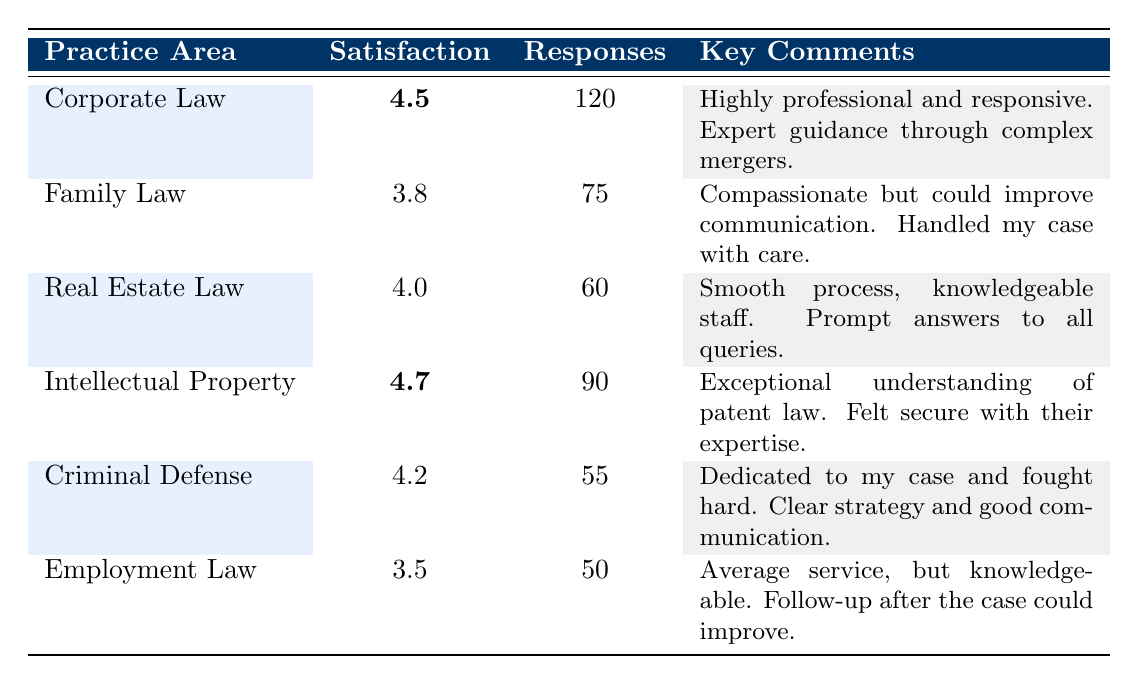What is the highest satisfaction rating among the practice areas? By examining the satisfaction ratings in the table, Intellectual Property has the highest rating at 4.7.
Answer: 4.7 How many responses were received for Family Law? The table shows that Family Law received 75 responses.
Answer: 75 What is the average satisfaction rating across all practice areas? To calculate the average satisfaction rating, we sum the ratings (4.5 + 3.8 + 4.0 + 4.7 + 4.2 + 3.5 = 24.7) and divide by the number of areas (6). Thus, the average is 24.7 / 6 = 4.12.
Answer: 4.12 Is the satisfaction rating for Employment Law higher than 4.0? The Employment Law satisfaction rating is 3.5, which is not higher than 4.0, making this statement false.
Answer: No Which practice area has the least number of responses? Looking at the number of responses, Employment Law has the least responses at 50, compared to the other areas.
Answer: Employment Law What satisfaction rating is below the average satisfaction rating calculated earlier? The previously calculated average satisfaction rating is 4.12. Comparing this with individual ratings, Family Law (3.8) and Employment Law (3.5) both fall below this average.
Answer: Family Law and Employment Law What is the total number of responses across all practice areas? Adding the responses (120 + 75 + 60 + 90 + 55 + 50) gives a total of 450 responses across all practice areas.
Answer: 450 Which practice area received a comment about communication improvement? The comment about communication improvement pertains to Family Law, which mentions that they could improve communication.
Answer: Family Law Is there a practice area with feedback mentioning "knowledgeable staff"? Yes, Real Estate Law received feedback that included comments about knowledgeable staff.
Answer: Yes 